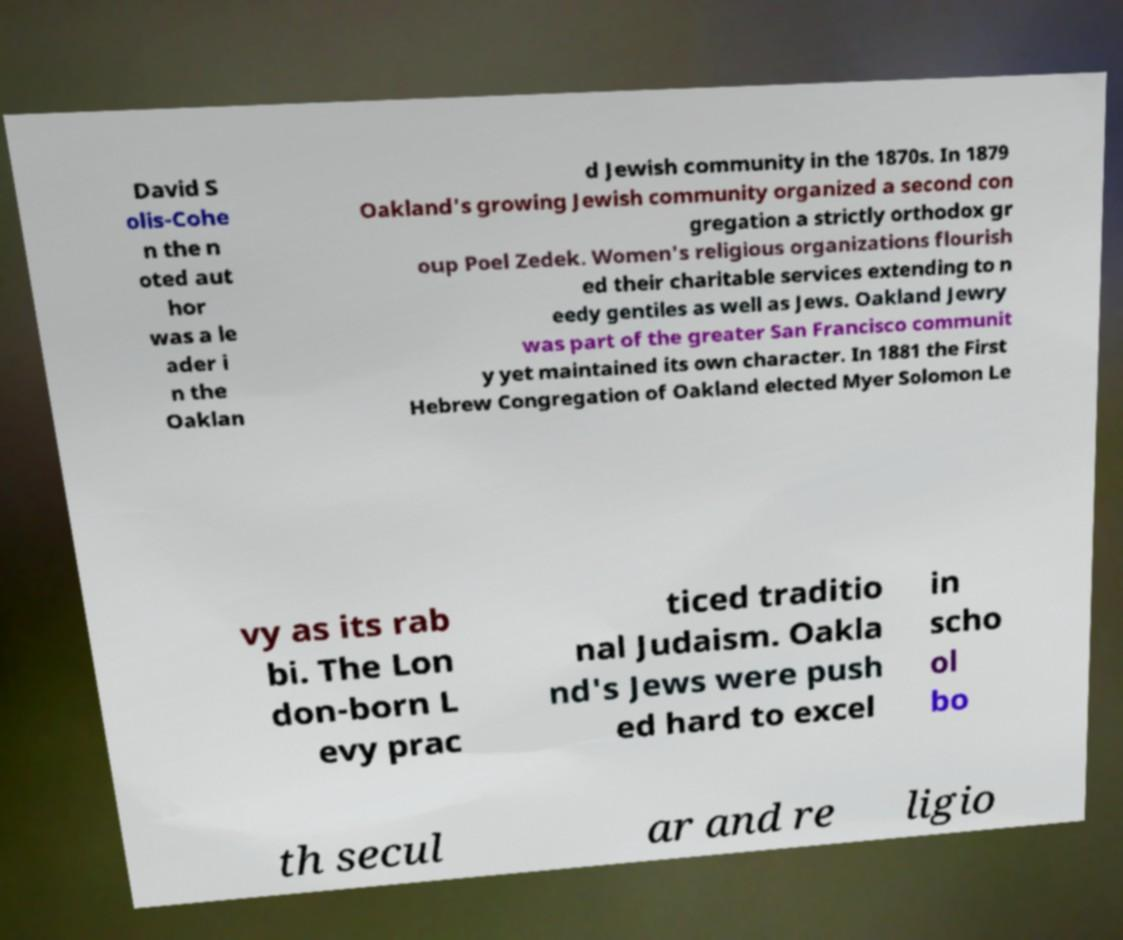I need the written content from this picture converted into text. Can you do that? David S olis-Cohe n the n oted aut hor was a le ader i n the Oaklan d Jewish community in the 1870s. In 1879 Oakland's growing Jewish community organized a second con gregation a strictly orthodox gr oup Poel Zedek. Women's religious organizations flourish ed their charitable services extending to n eedy gentiles as well as Jews. Oakland Jewry was part of the greater San Francisco communit y yet maintained its own character. In 1881 the First Hebrew Congregation of Oakland elected Myer Solomon Le vy as its rab bi. The Lon don-born L evy prac ticed traditio nal Judaism. Oakla nd's Jews were push ed hard to excel in scho ol bo th secul ar and re ligio 